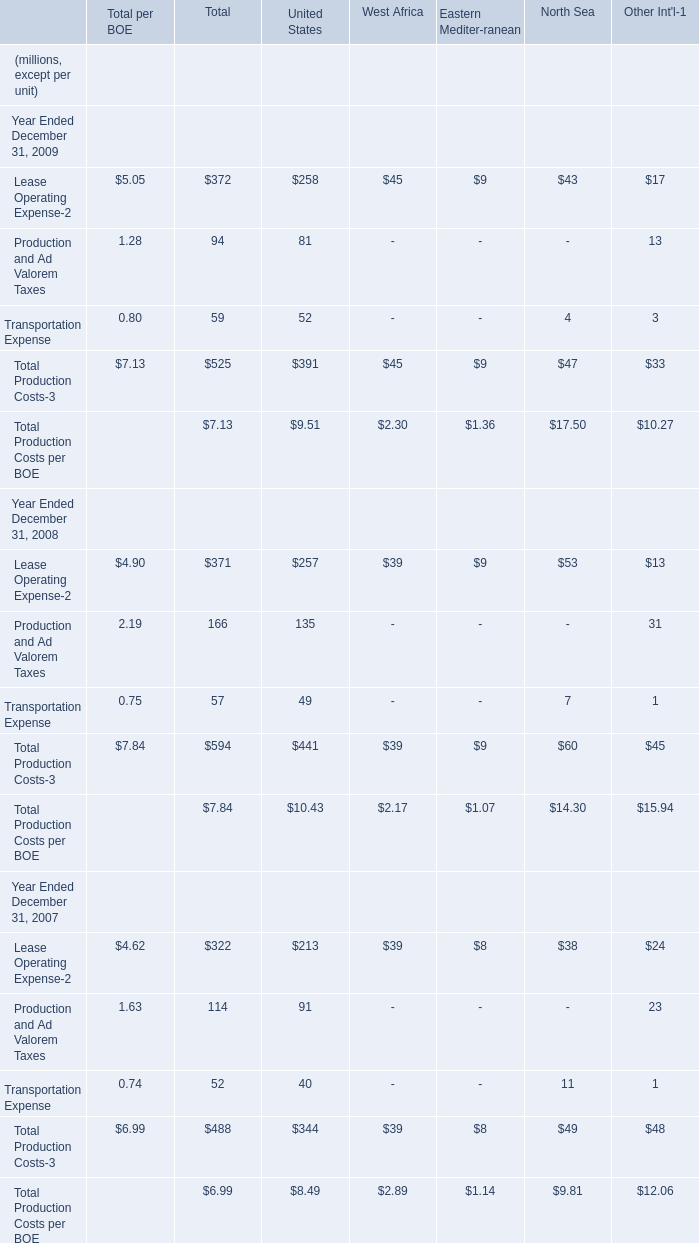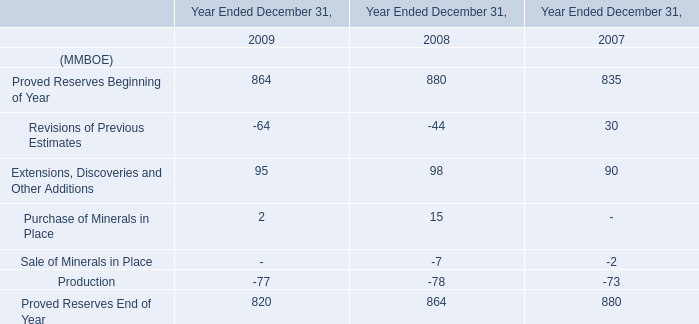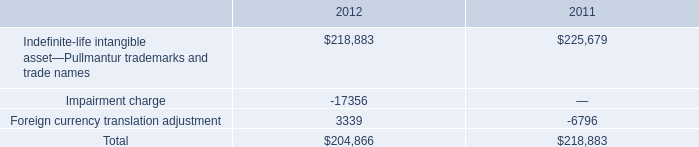what was the percentage decline in the value of the intangible assets from 2011 to 2012 
Computations: ((204866 - 218883) / 218883)
Answer: -0.06404. 